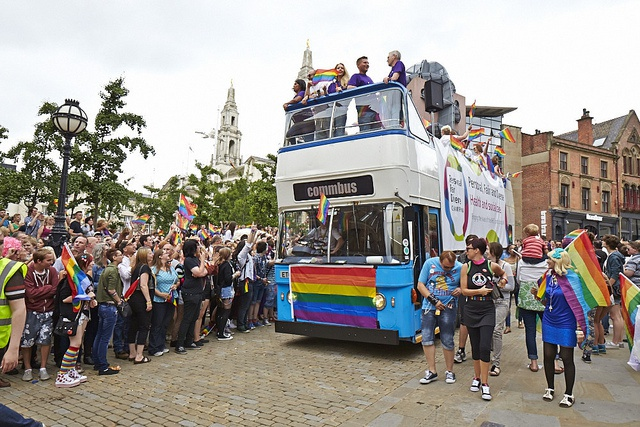Describe the objects in this image and their specific colors. I can see people in white, black, gray, darkgray, and lightgray tones, bus in white, lightgray, black, darkgray, and gray tones, people in white, black, gray, and maroon tones, people in white, gray, and black tones, and people in white, black, navy, blue, and darkblue tones in this image. 